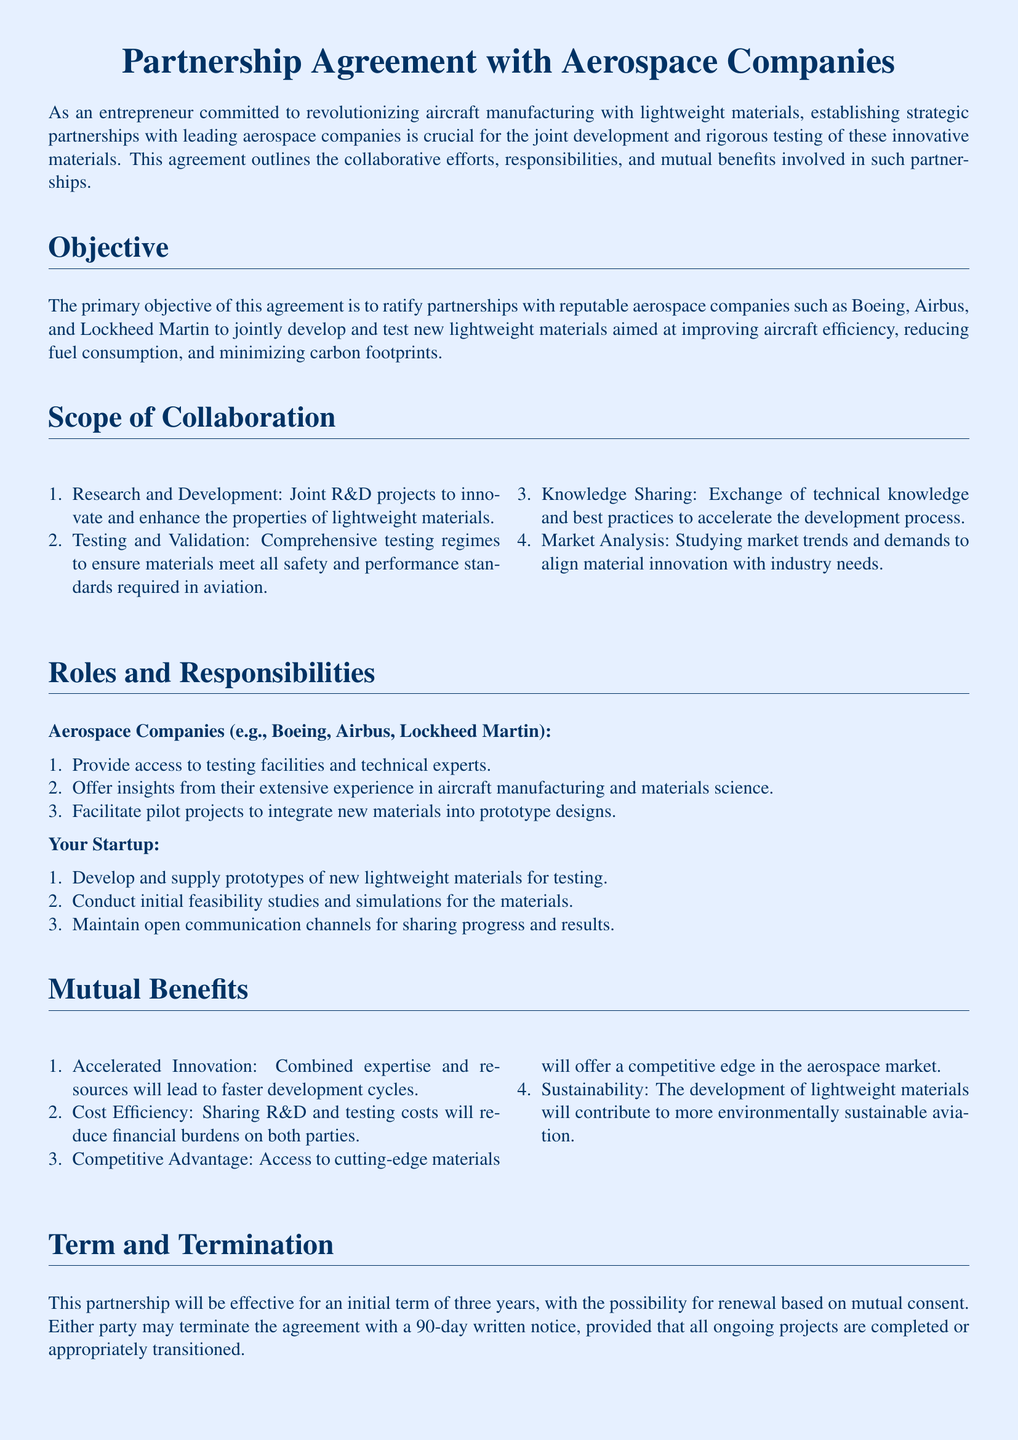What are the leading aerospace companies mentioned? The document lists Boeing, Airbus, and Lockheed Martin as leading aerospace companies for collaboration.
Answer: Boeing, Airbus, Lockheed Martin How long is the initial term of the partnership? The partnership is effective for an initial term specified in the document.
Answer: three years What type of projects will the partnership focus on? The document specifies joint projects related to lightweight materials in aircraft manufacturing.
Answer: lightweight materials What is one responsibility of the aerospace companies? The document outlines specific responsibilities for the aerospace companies, including insights and access to facilities.
Answer: Provide access to testing facilities What is a mutual benefit cited in the agreement? The document enumerates several mutual benefits that will arise from the partnership.
Answer: Accelerated Innovation What is required for either party to terminate the agreement? The document states the protocol for terminating the agreement including a specific notice period.
Answer: 90-day written notice Which aspect of collaboration involves studying market conditions? The document lists responsibilities regarding market analysis as part of the collaboration.
Answer: Market Analysis What confidentiality measure is included in the agreement? The document emphasizes the importance of safeguarding proprietary information during the partnership.
Answer: Confidentiality protocols What will your startup develop for testing? The responsibilities of your startup include supplying prototypes as outlined in the document.
Answer: Prototypes of new lightweight materials 